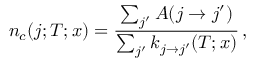Convert formula to latex. <formula><loc_0><loc_0><loc_500><loc_500>n _ { c } ( j ; T ; x ) = \frac { \sum _ { j ^ { \prime } } A ( j \rightarrow j ^ { \prime } ) } { \sum _ { j ^ { \prime } } k _ { j \rightarrow j ^ { \prime } } ( T ; x ) } \, ,</formula> 